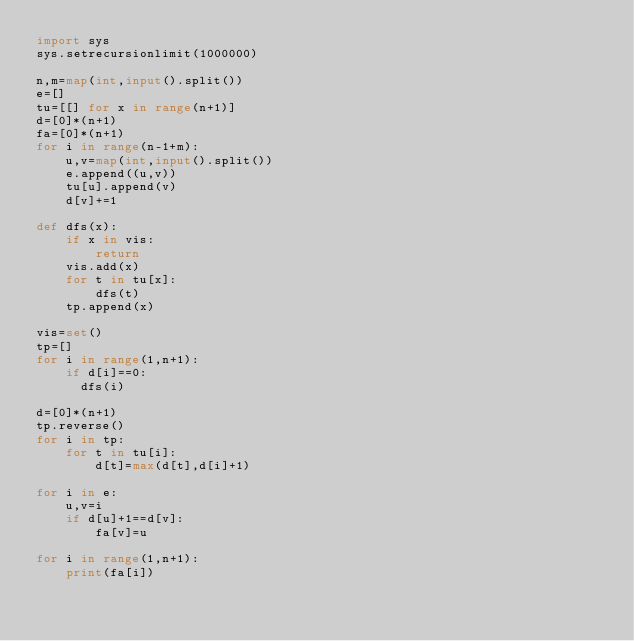<code> <loc_0><loc_0><loc_500><loc_500><_Python_>import sys
sys.setrecursionlimit(1000000)

n,m=map(int,input().split())
e=[]
tu=[[] for x in range(n+1)]
d=[0]*(n+1)
fa=[0]*(n+1)
for i in range(n-1+m):
    u,v=map(int,input().split())
    e.append((u,v))
    tu[u].append(v)
    d[v]+=1

def dfs(x):
    if x in vis:
        return
    vis.add(x)
    for t in tu[x]:
        dfs(t)
    tp.append(x)

vis=set()
tp=[]
for i in range(1,n+1):
    if d[i]==0:
      dfs(i)

d=[0]*(n+1)
tp.reverse()
for i in tp:
    for t in tu[i]:
        d[t]=max(d[t],d[i]+1)

for i in e:
    u,v=i
    if d[u]+1==d[v]:
        fa[v]=u

for i in range(1,n+1):
    print(fa[i])
</code> 